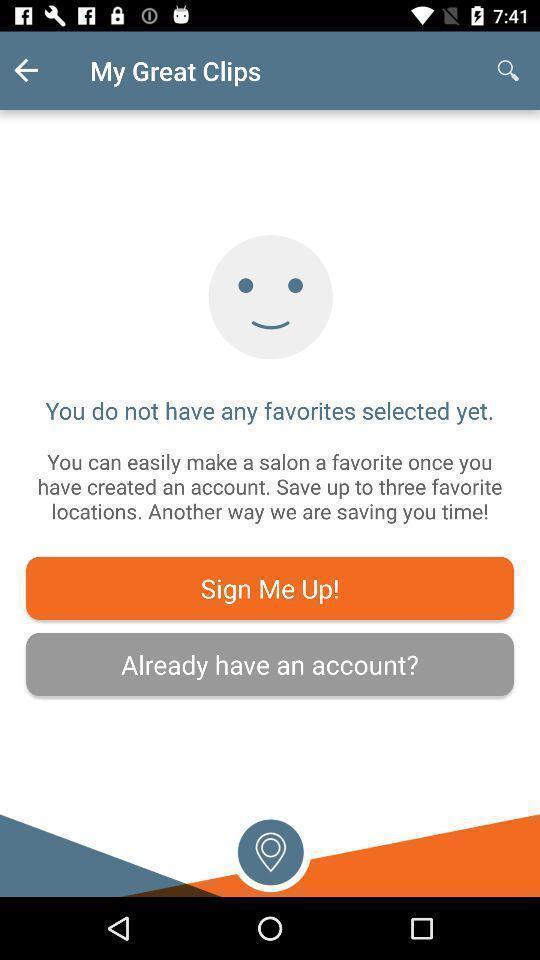What is the overall content of this screenshot? Sign in page for saving clips. 